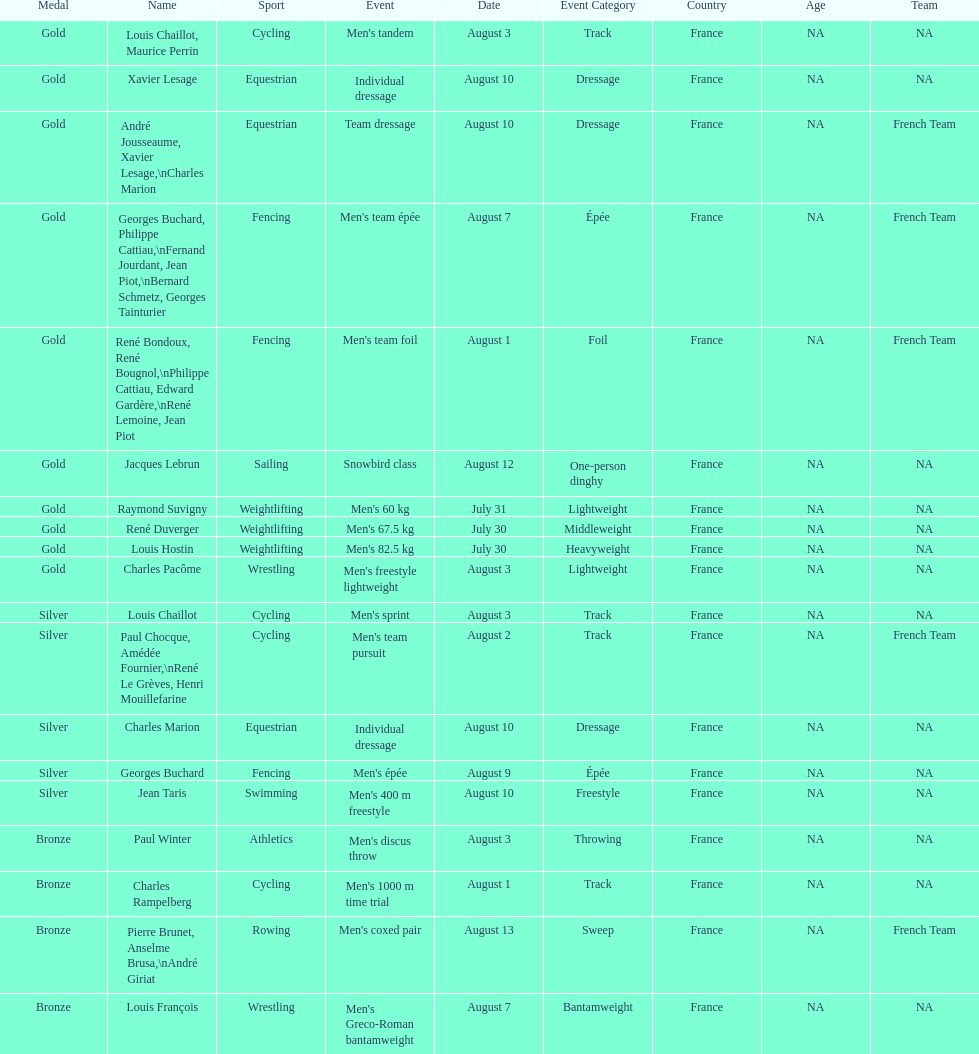What is next date that is listed after august 7th? August 1. 